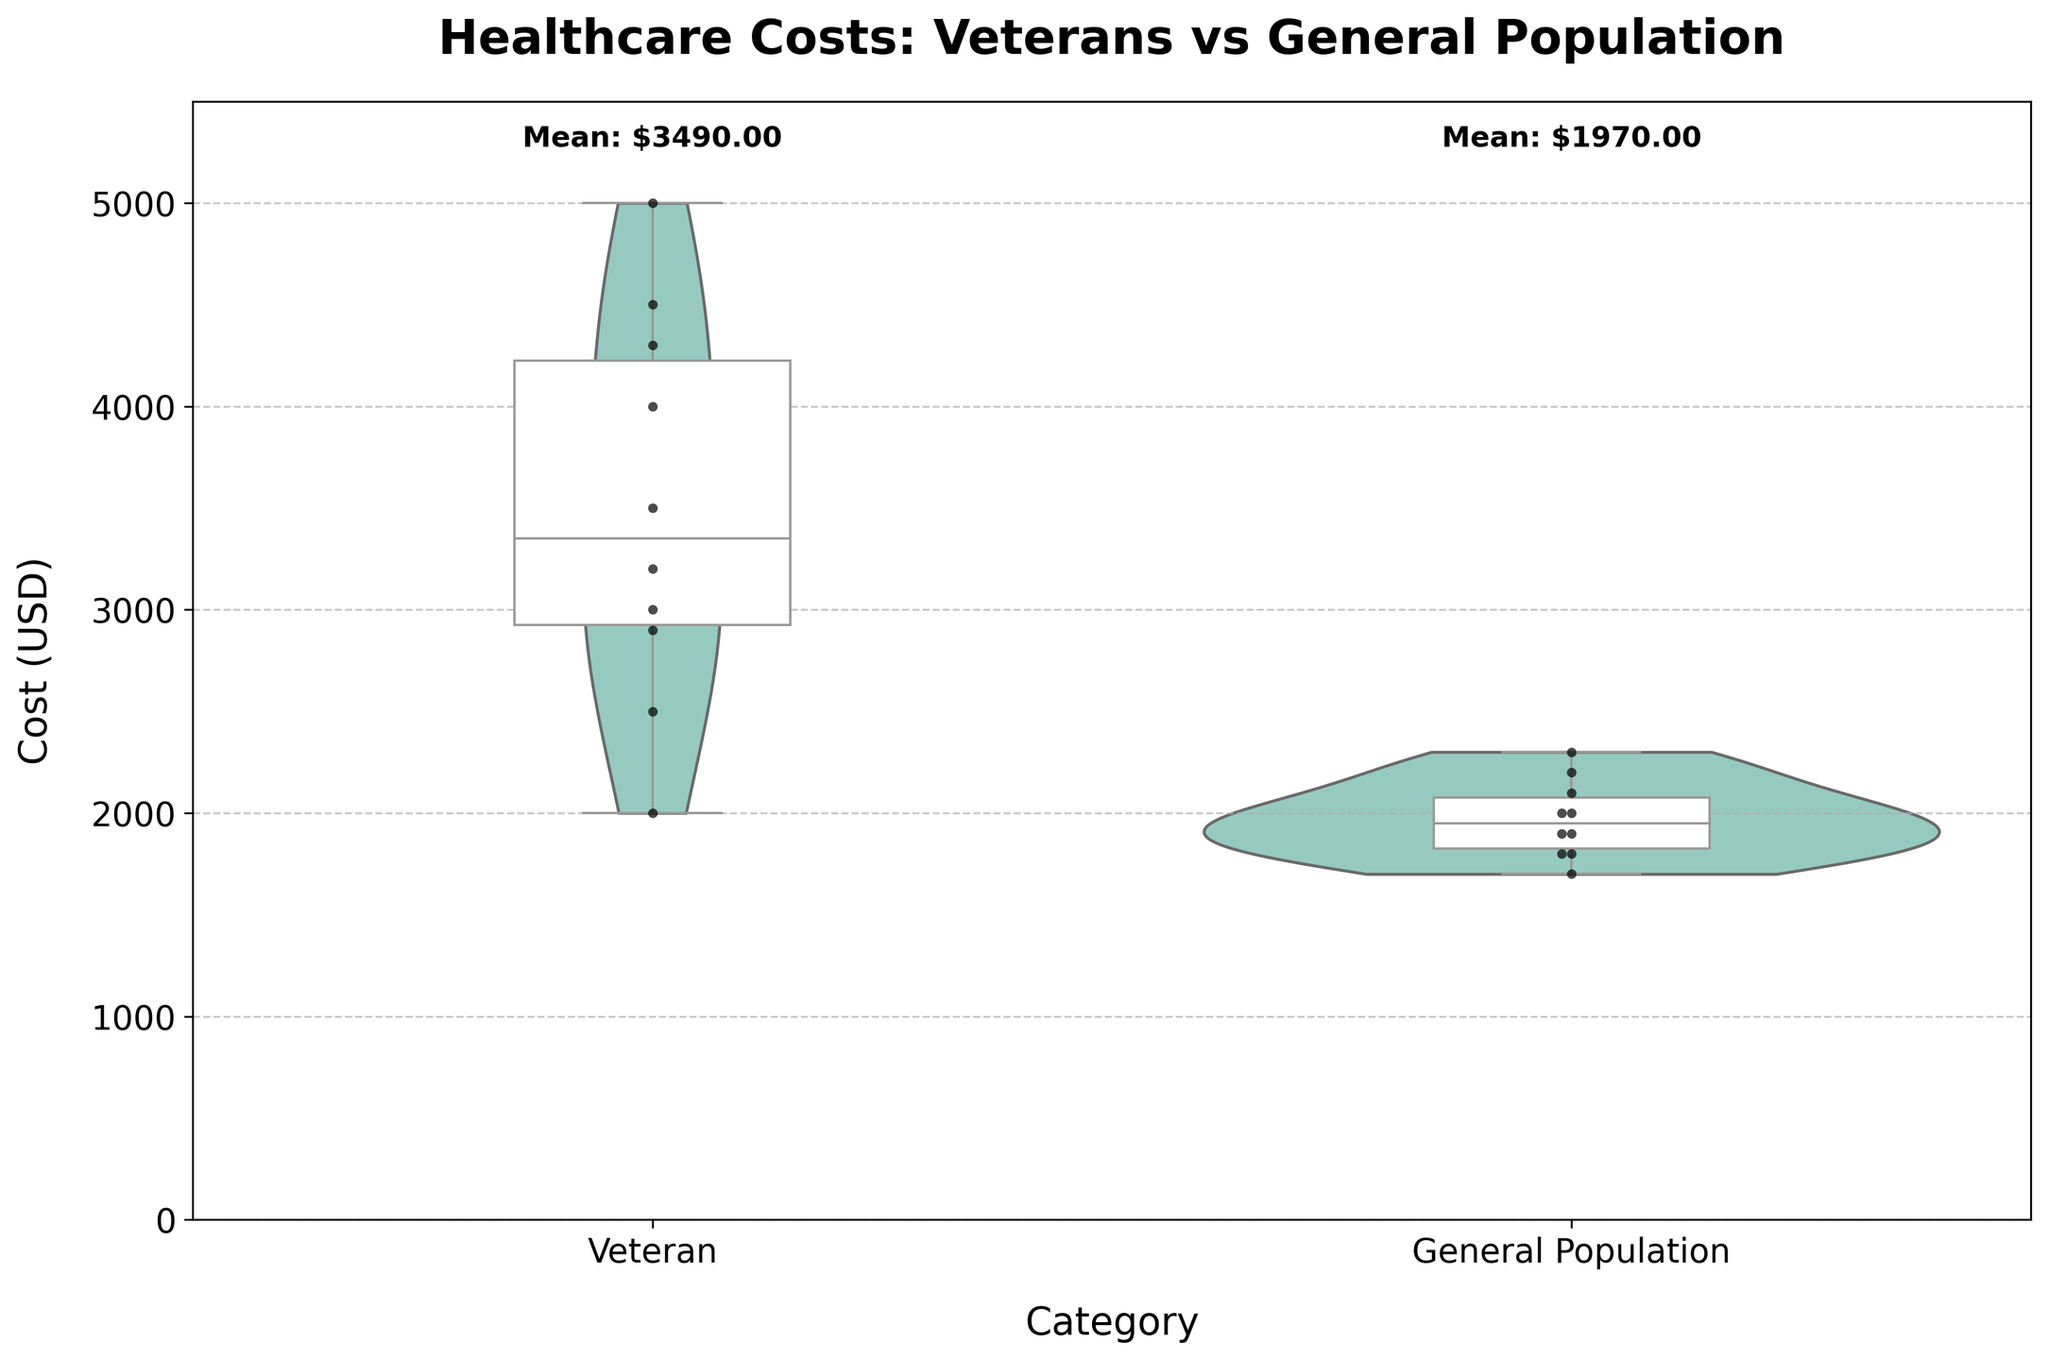What is the title of the plot? The title is located at the top of the plot and is usually the largest and boldest text. By reading it, you can understand the subject of the data.
Answer: Healthcare Costs: Veterans vs General Population What are the categories compared in the plot? The x-axis labels represent the categories being compared. Look for the labels directly under each violin and box plot.
Answer: Veteran and General Population What color palette is used for the violin plots? The color of the violin plots can be observed; different categories have their own distinct colors. The legend or palette description might also help. The plot uses the "Set3" palette.
Answer: Various colors (part of "Set3" palette) Which group has the highest individual healthcare cost point? The highest individual points can be identified within the scatter points overlaid on the violin plots. Check the highest point in each category.
Answer: Veteran What is the mean healthcare cost for veterans? The text annotation above the veteran category gives the mean value already calculated. Look above the veteran plot for this value.
Answer: $34,400 Is the median healthcare cost higher for veterans or the general population? The median can be determined by the line inside the middle of each box plot. Compare these lines between the two categories.
Answer: Veterans What is the maximum healthcare cost observed in the general population? The highest point on the y-axis within the general population category represents the maximum cost. Look at the highest black dot in the general population plot.
Answer: $2,300 What's the range (difference between the maximum and minimum) of healthcare costs for veterans? The range can be found by subtracting the smallest value from the largest value within the veteran category, observed from the outer points of the violin plot.
Answer: $3,000 Do veterans have a wider range of healthcare costs compared to the general population? Compare the spread of the data points from top to bottom in both categories. The width of the violin plots or the distance between whiskers of the box plots indicates this.
Answer: Yes What does the distribution of healthcare costs for the general population look like compared to veterans? The shape and spread of the violin plot provide this information. A wider and taller distribution indicates more variability. Compare the violin plot shapes of both categories.
Answer: The general population has a more concentrated and less varied distribution 